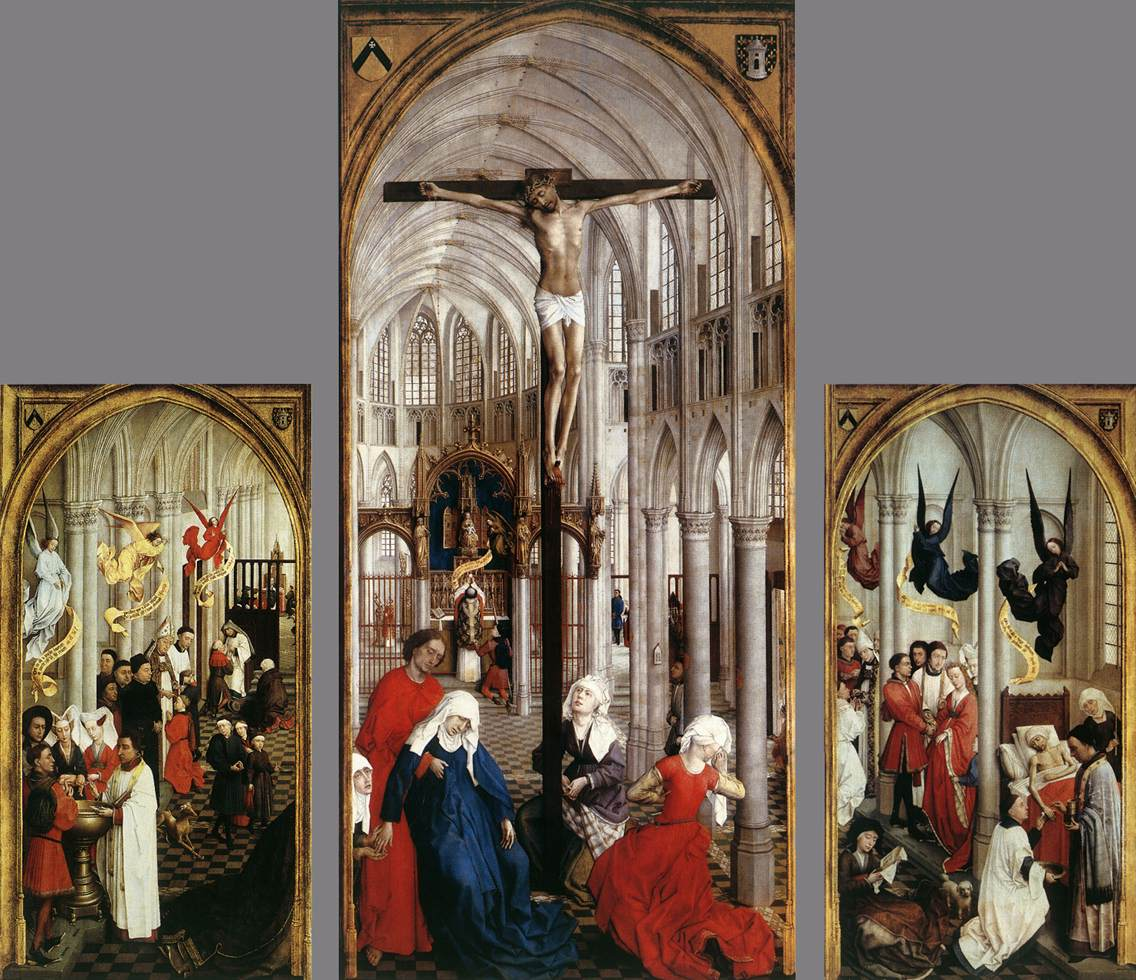How do the architectural elements enhance the thematic expression in this triptych? The Gothic architectural elements, with their lofty arches and intricate stonework, amplify the thematic expression of celestial grandeur and divine order. These structures frame the central panel's crucifixion, drawing viewer's eyes upwards, symbolizing a connection to the divine. The spatial depth and perspective created by these architectural features not only enhance the visual impact but also metaphorically underline the transition from earthly existence to spiritual transcendence. 